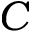Convert formula to latex. <formula><loc_0><loc_0><loc_500><loc_500>{ C }</formula> 